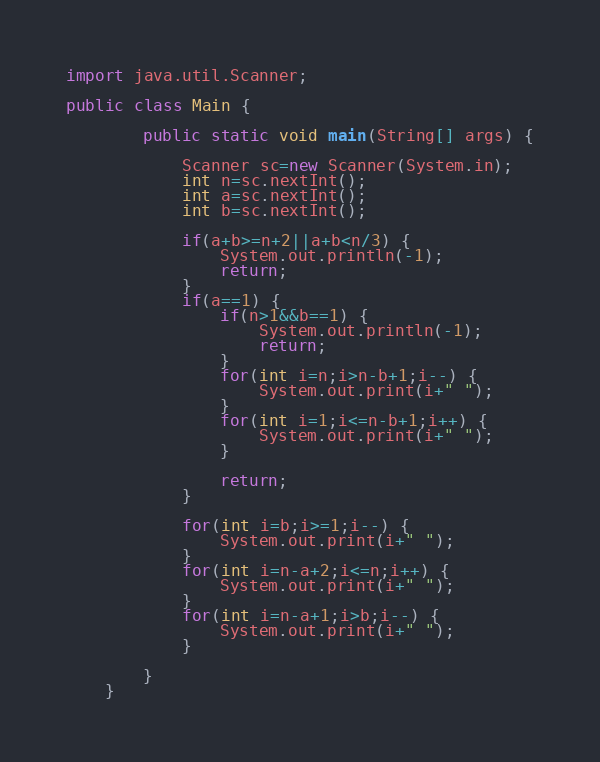Convert code to text. <code><loc_0><loc_0><loc_500><loc_500><_Java_>import java.util.Scanner;

public class Main {

		public static void main(String[] args) {

			Scanner sc=new Scanner(System.in);
			int n=sc.nextInt();
			int a=sc.nextInt();
			int b=sc.nextInt();
			
			if(a+b>=n+2||a+b<n/3) {
				System.out.println(-1);
				return;
			}
			if(a==1) {
				if(n>1&&b==1) {
					System.out.println(-1);
					return;
				}
				for(int i=n;i>n-b+1;i--) {
					System.out.print(i+" ");
				}
				for(int i=1;i<=n-b+1;i++) {
					System.out.print(i+" ");
				}
				
				return;
			}
			
			for(int i=b;i>=1;i--) {
				System.out.print(i+" ");
			}
			for(int i=n-a+2;i<=n;i++) {
				System.out.print(i+" ");
			}
			for(int i=n-a+1;i>b;i--) {
				System.out.print(i+" ");
			}
			
		}
	}

</code> 